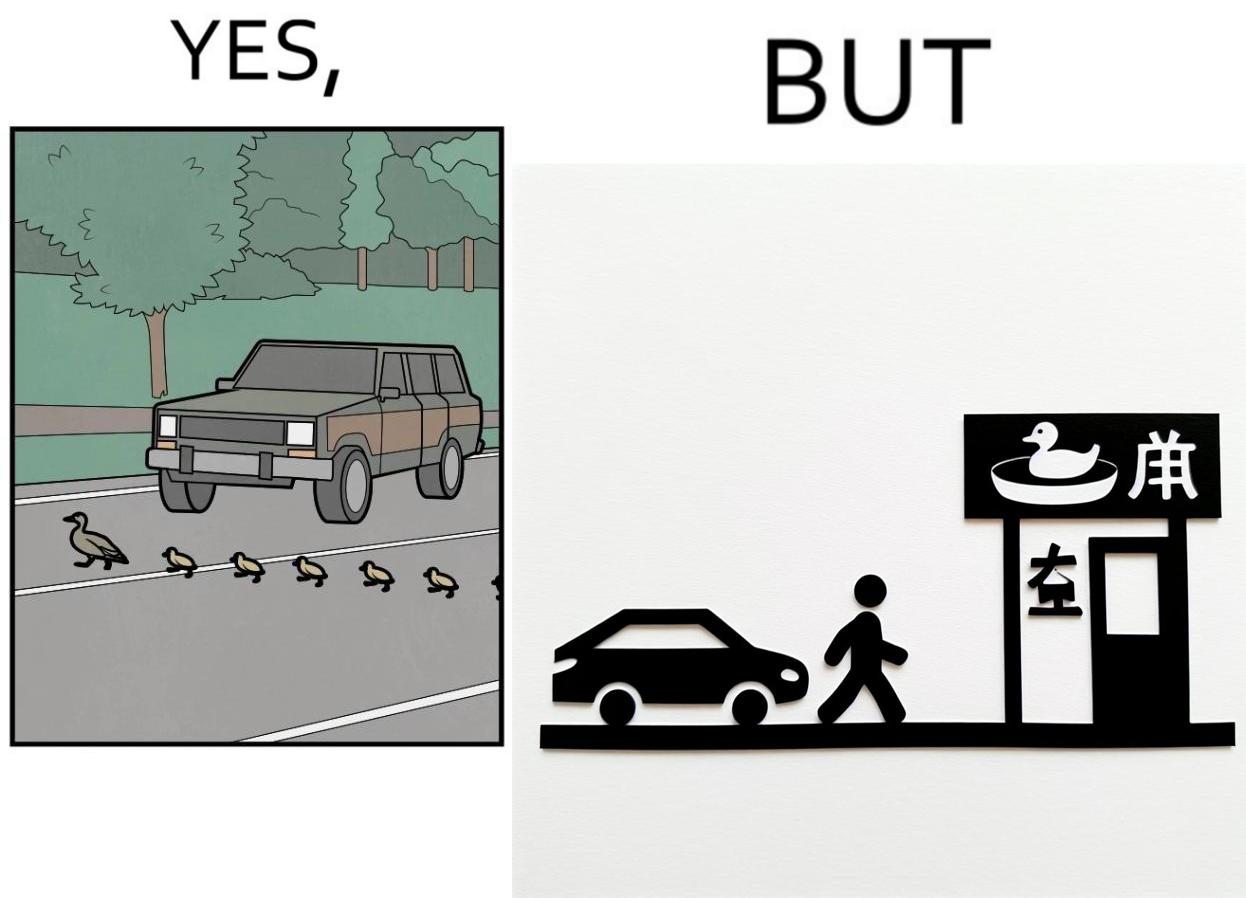Explain why this image is satirical. The images are ironic since they show how a man supposedly cares for ducks since he stops his vehicle to give way to queue of ducks allowing them to safely cross a road but on the other hand he goes to a peking duck shop to buy and eat similar ducks after having them killed 